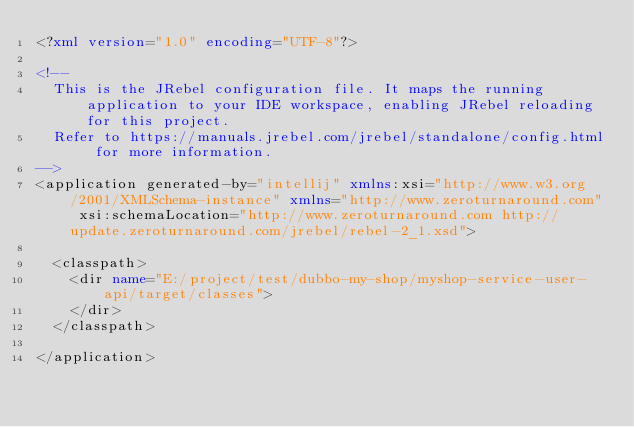Convert code to text. <code><loc_0><loc_0><loc_500><loc_500><_XML_><?xml version="1.0" encoding="UTF-8"?>

<!--
  This is the JRebel configuration file. It maps the running application to your IDE workspace, enabling JRebel reloading for this project.
  Refer to https://manuals.jrebel.com/jrebel/standalone/config.html for more information.
-->
<application generated-by="intellij" xmlns:xsi="http://www.w3.org/2001/XMLSchema-instance" xmlns="http://www.zeroturnaround.com" xsi:schemaLocation="http://www.zeroturnaround.com http://update.zeroturnaround.com/jrebel/rebel-2_1.xsd">

	<classpath>
		<dir name="E:/project/test/dubbo-my-shop/myshop-service-user-api/target/classes">
		</dir>
	</classpath>

</application>
</code> 